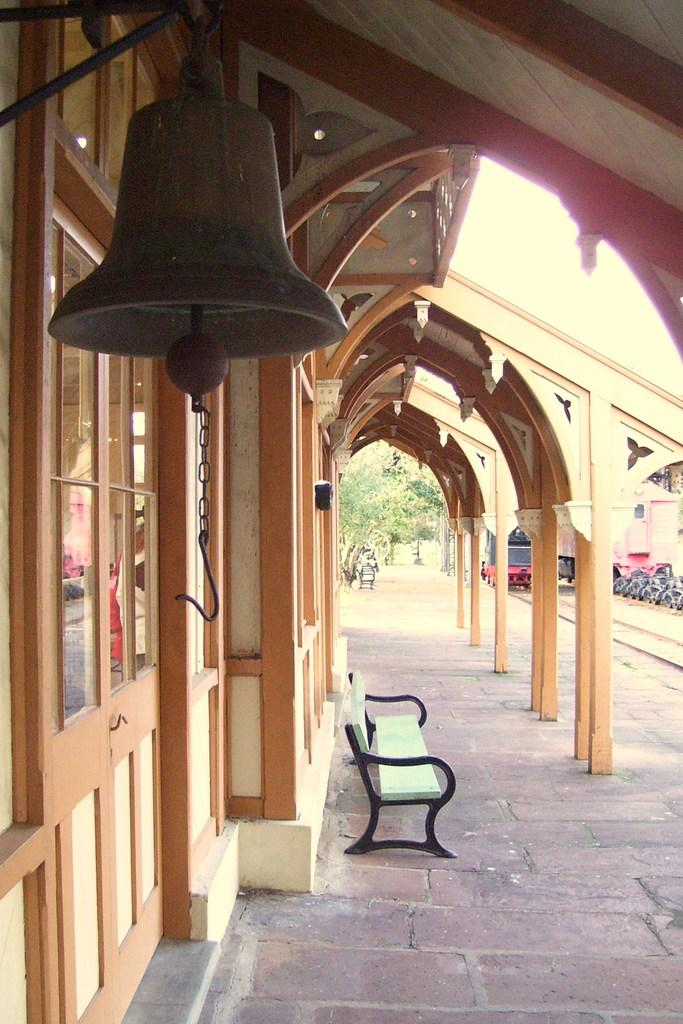What object can be seen hanging in the image? There is a bell in the image. What type of seating is present in the image? There is a bench in the image. Where is the bench located? The bench is on a porch in the image. What can be seen on the left side of the image? There is a glass on the left side of the image. What type of natural scenery is visible in the background of the image? There are trees in the background of the image. What type of mine can be seen in the background of the image? There is no mine present in the image; it features a bell, bench, porch, glass, and trees. How many people are seen kissing in the image? There are no people kissing in the image. 